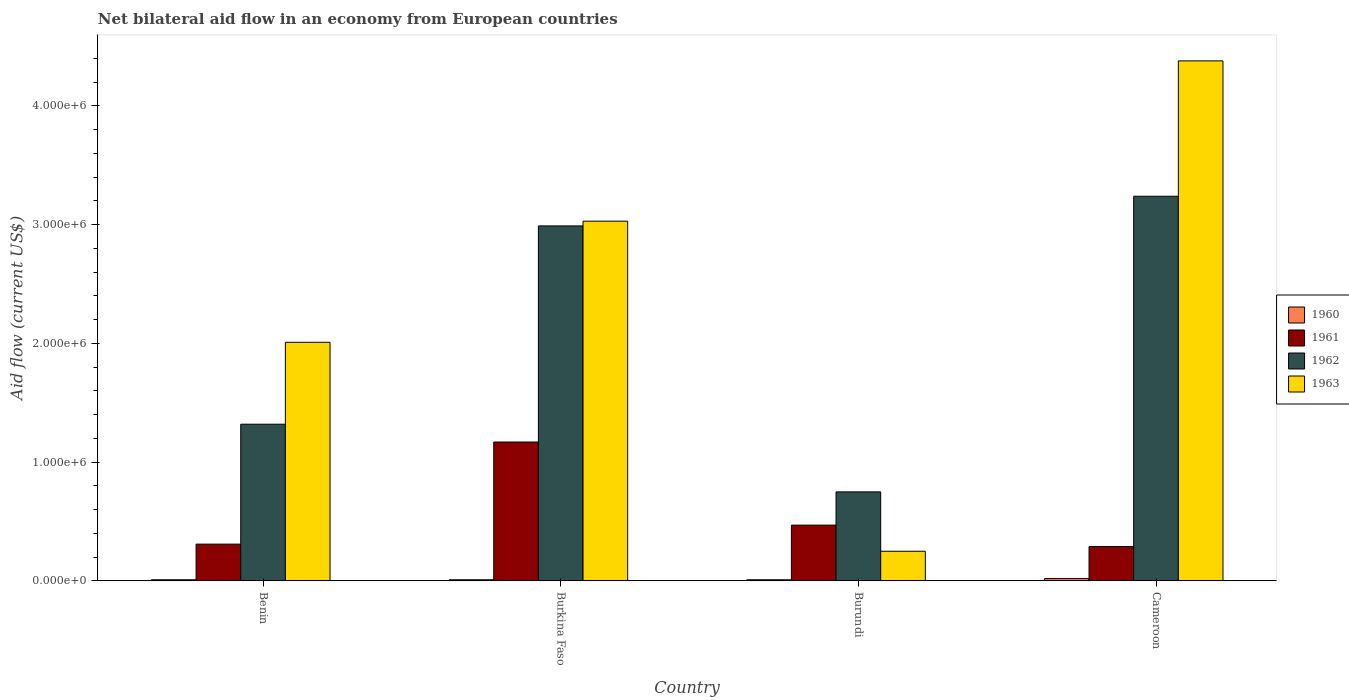How many groups of bars are there?
Ensure brevity in your answer.  4. Are the number of bars per tick equal to the number of legend labels?
Offer a very short reply. Yes. How many bars are there on the 3rd tick from the right?
Your answer should be very brief. 4. What is the label of the 1st group of bars from the left?
Offer a very short reply. Benin. Across all countries, what is the maximum net bilateral aid flow in 1963?
Offer a terse response. 4.38e+06. Across all countries, what is the minimum net bilateral aid flow in 1960?
Ensure brevity in your answer.  10000. In which country was the net bilateral aid flow in 1963 maximum?
Offer a terse response. Cameroon. In which country was the net bilateral aid flow in 1962 minimum?
Offer a very short reply. Burundi. What is the total net bilateral aid flow in 1961 in the graph?
Keep it short and to the point. 2.24e+06. What is the difference between the net bilateral aid flow in 1962 in Burundi and the net bilateral aid flow in 1963 in Burkina Faso?
Make the answer very short. -2.28e+06. What is the average net bilateral aid flow in 1962 per country?
Give a very brief answer. 2.08e+06. What is the difference between the net bilateral aid flow of/in 1961 and net bilateral aid flow of/in 1962 in Burkina Faso?
Keep it short and to the point. -1.82e+06. What is the ratio of the net bilateral aid flow in 1961 in Burkina Faso to that in Burundi?
Your response must be concise. 2.49. Is the net bilateral aid flow in 1960 in Benin less than that in Cameroon?
Offer a terse response. Yes. What is the difference between the highest and the lowest net bilateral aid flow in 1962?
Ensure brevity in your answer.  2.49e+06. In how many countries, is the net bilateral aid flow in 1963 greater than the average net bilateral aid flow in 1963 taken over all countries?
Your response must be concise. 2. Is it the case that in every country, the sum of the net bilateral aid flow in 1960 and net bilateral aid flow in 1962 is greater than the sum of net bilateral aid flow in 1961 and net bilateral aid flow in 1963?
Your answer should be very brief. No. What does the 2nd bar from the left in Cameroon represents?
Keep it short and to the point. 1961. What does the 3rd bar from the right in Cameroon represents?
Your answer should be very brief. 1961. How many bars are there?
Ensure brevity in your answer.  16. Are the values on the major ticks of Y-axis written in scientific E-notation?
Give a very brief answer. Yes. Does the graph contain any zero values?
Give a very brief answer. No. What is the title of the graph?
Give a very brief answer. Net bilateral aid flow in an economy from European countries. Does "1985" appear as one of the legend labels in the graph?
Offer a very short reply. No. What is the Aid flow (current US$) of 1962 in Benin?
Your answer should be very brief. 1.32e+06. What is the Aid flow (current US$) in 1963 in Benin?
Provide a succinct answer. 2.01e+06. What is the Aid flow (current US$) in 1961 in Burkina Faso?
Your answer should be compact. 1.17e+06. What is the Aid flow (current US$) in 1962 in Burkina Faso?
Ensure brevity in your answer.  2.99e+06. What is the Aid flow (current US$) in 1963 in Burkina Faso?
Offer a very short reply. 3.03e+06. What is the Aid flow (current US$) of 1961 in Burundi?
Offer a terse response. 4.70e+05. What is the Aid flow (current US$) in 1962 in Burundi?
Your answer should be compact. 7.50e+05. What is the Aid flow (current US$) of 1960 in Cameroon?
Keep it short and to the point. 2.00e+04. What is the Aid flow (current US$) of 1962 in Cameroon?
Provide a succinct answer. 3.24e+06. What is the Aid flow (current US$) in 1963 in Cameroon?
Give a very brief answer. 4.38e+06. Across all countries, what is the maximum Aid flow (current US$) in 1960?
Your response must be concise. 2.00e+04. Across all countries, what is the maximum Aid flow (current US$) of 1961?
Your answer should be compact. 1.17e+06. Across all countries, what is the maximum Aid flow (current US$) of 1962?
Give a very brief answer. 3.24e+06. Across all countries, what is the maximum Aid flow (current US$) of 1963?
Make the answer very short. 4.38e+06. Across all countries, what is the minimum Aid flow (current US$) in 1961?
Keep it short and to the point. 2.90e+05. Across all countries, what is the minimum Aid flow (current US$) of 1962?
Provide a short and direct response. 7.50e+05. What is the total Aid flow (current US$) in 1960 in the graph?
Provide a succinct answer. 5.00e+04. What is the total Aid flow (current US$) in 1961 in the graph?
Provide a succinct answer. 2.24e+06. What is the total Aid flow (current US$) of 1962 in the graph?
Keep it short and to the point. 8.30e+06. What is the total Aid flow (current US$) in 1963 in the graph?
Ensure brevity in your answer.  9.67e+06. What is the difference between the Aid flow (current US$) in 1960 in Benin and that in Burkina Faso?
Provide a short and direct response. 0. What is the difference between the Aid flow (current US$) of 1961 in Benin and that in Burkina Faso?
Give a very brief answer. -8.60e+05. What is the difference between the Aid flow (current US$) of 1962 in Benin and that in Burkina Faso?
Ensure brevity in your answer.  -1.67e+06. What is the difference between the Aid flow (current US$) in 1963 in Benin and that in Burkina Faso?
Give a very brief answer. -1.02e+06. What is the difference between the Aid flow (current US$) of 1961 in Benin and that in Burundi?
Keep it short and to the point. -1.60e+05. What is the difference between the Aid flow (current US$) in 1962 in Benin and that in Burundi?
Ensure brevity in your answer.  5.70e+05. What is the difference between the Aid flow (current US$) in 1963 in Benin and that in Burundi?
Keep it short and to the point. 1.76e+06. What is the difference between the Aid flow (current US$) of 1960 in Benin and that in Cameroon?
Your answer should be compact. -10000. What is the difference between the Aid flow (current US$) in 1962 in Benin and that in Cameroon?
Your answer should be compact. -1.92e+06. What is the difference between the Aid flow (current US$) of 1963 in Benin and that in Cameroon?
Ensure brevity in your answer.  -2.37e+06. What is the difference between the Aid flow (current US$) of 1961 in Burkina Faso and that in Burundi?
Ensure brevity in your answer.  7.00e+05. What is the difference between the Aid flow (current US$) of 1962 in Burkina Faso and that in Burundi?
Provide a short and direct response. 2.24e+06. What is the difference between the Aid flow (current US$) in 1963 in Burkina Faso and that in Burundi?
Keep it short and to the point. 2.78e+06. What is the difference between the Aid flow (current US$) in 1960 in Burkina Faso and that in Cameroon?
Your response must be concise. -10000. What is the difference between the Aid flow (current US$) in 1961 in Burkina Faso and that in Cameroon?
Ensure brevity in your answer.  8.80e+05. What is the difference between the Aid flow (current US$) in 1962 in Burkina Faso and that in Cameroon?
Offer a terse response. -2.50e+05. What is the difference between the Aid flow (current US$) in 1963 in Burkina Faso and that in Cameroon?
Your answer should be very brief. -1.35e+06. What is the difference between the Aid flow (current US$) in 1960 in Burundi and that in Cameroon?
Keep it short and to the point. -10000. What is the difference between the Aid flow (current US$) in 1961 in Burundi and that in Cameroon?
Provide a succinct answer. 1.80e+05. What is the difference between the Aid flow (current US$) of 1962 in Burundi and that in Cameroon?
Offer a very short reply. -2.49e+06. What is the difference between the Aid flow (current US$) of 1963 in Burundi and that in Cameroon?
Keep it short and to the point. -4.13e+06. What is the difference between the Aid flow (current US$) of 1960 in Benin and the Aid flow (current US$) of 1961 in Burkina Faso?
Offer a very short reply. -1.16e+06. What is the difference between the Aid flow (current US$) in 1960 in Benin and the Aid flow (current US$) in 1962 in Burkina Faso?
Offer a terse response. -2.98e+06. What is the difference between the Aid flow (current US$) of 1960 in Benin and the Aid flow (current US$) of 1963 in Burkina Faso?
Give a very brief answer. -3.02e+06. What is the difference between the Aid flow (current US$) of 1961 in Benin and the Aid flow (current US$) of 1962 in Burkina Faso?
Offer a terse response. -2.68e+06. What is the difference between the Aid flow (current US$) in 1961 in Benin and the Aid flow (current US$) in 1963 in Burkina Faso?
Provide a short and direct response. -2.72e+06. What is the difference between the Aid flow (current US$) of 1962 in Benin and the Aid flow (current US$) of 1963 in Burkina Faso?
Your response must be concise. -1.71e+06. What is the difference between the Aid flow (current US$) in 1960 in Benin and the Aid flow (current US$) in 1961 in Burundi?
Provide a succinct answer. -4.60e+05. What is the difference between the Aid flow (current US$) of 1960 in Benin and the Aid flow (current US$) of 1962 in Burundi?
Keep it short and to the point. -7.40e+05. What is the difference between the Aid flow (current US$) in 1961 in Benin and the Aid flow (current US$) in 1962 in Burundi?
Provide a short and direct response. -4.40e+05. What is the difference between the Aid flow (current US$) of 1961 in Benin and the Aid flow (current US$) of 1963 in Burundi?
Your answer should be very brief. 6.00e+04. What is the difference between the Aid flow (current US$) in 1962 in Benin and the Aid flow (current US$) in 1963 in Burundi?
Keep it short and to the point. 1.07e+06. What is the difference between the Aid flow (current US$) of 1960 in Benin and the Aid flow (current US$) of 1961 in Cameroon?
Provide a short and direct response. -2.80e+05. What is the difference between the Aid flow (current US$) in 1960 in Benin and the Aid flow (current US$) in 1962 in Cameroon?
Your response must be concise. -3.23e+06. What is the difference between the Aid flow (current US$) of 1960 in Benin and the Aid flow (current US$) of 1963 in Cameroon?
Make the answer very short. -4.37e+06. What is the difference between the Aid flow (current US$) of 1961 in Benin and the Aid flow (current US$) of 1962 in Cameroon?
Ensure brevity in your answer.  -2.93e+06. What is the difference between the Aid flow (current US$) in 1961 in Benin and the Aid flow (current US$) in 1963 in Cameroon?
Make the answer very short. -4.07e+06. What is the difference between the Aid flow (current US$) of 1962 in Benin and the Aid flow (current US$) of 1963 in Cameroon?
Offer a very short reply. -3.06e+06. What is the difference between the Aid flow (current US$) of 1960 in Burkina Faso and the Aid flow (current US$) of 1961 in Burundi?
Make the answer very short. -4.60e+05. What is the difference between the Aid flow (current US$) of 1960 in Burkina Faso and the Aid flow (current US$) of 1962 in Burundi?
Your answer should be compact. -7.40e+05. What is the difference between the Aid flow (current US$) in 1961 in Burkina Faso and the Aid flow (current US$) in 1963 in Burundi?
Provide a short and direct response. 9.20e+05. What is the difference between the Aid flow (current US$) of 1962 in Burkina Faso and the Aid flow (current US$) of 1963 in Burundi?
Ensure brevity in your answer.  2.74e+06. What is the difference between the Aid flow (current US$) of 1960 in Burkina Faso and the Aid flow (current US$) of 1961 in Cameroon?
Provide a succinct answer. -2.80e+05. What is the difference between the Aid flow (current US$) of 1960 in Burkina Faso and the Aid flow (current US$) of 1962 in Cameroon?
Your answer should be compact. -3.23e+06. What is the difference between the Aid flow (current US$) in 1960 in Burkina Faso and the Aid flow (current US$) in 1963 in Cameroon?
Make the answer very short. -4.37e+06. What is the difference between the Aid flow (current US$) in 1961 in Burkina Faso and the Aid flow (current US$) in 1962 in Cameroon?
Give a very brief answer. -2.07e+06. What is the difference between the Aid flow (current US$) in 1961 in Burkina Faso and the Aid flow (current US$) in 1963 in Cameroon?
Make the answer very short. -3.21e+06. What is the difference between the Aid flow (current US$) of 1962 in Burkina Faso and the Aid flow (current US$) of 1963 in Cameroon?
Provide a short and direct response. -1.39e+06. What is the difference between the Aid flow (current US$) of 1960 in Burundi and the Aid flow (current US$) of 1961 in Cameroon?
Provide a succinct answer. -2.80e+05. What is the difference between the Aid flow (current US$) in 1960 in Burundi and the Aid flow (current US$) in 1962 in Cameroon?
Offer a terse response. -3.23e+06. What is the difference between the Aid flow (current US$) in 1960 in Burundi and the Aid flow (current US$) in 1963 in Cameroon?
Offer a terse response. -4.37e+06. What is the difference between the Aid flow (current US$) of 1961 in Burundi and the Aid flow (current US$) of 1962 in Cameroon?
Provide a short and direct response. -2.77e+06. What is the difference between the Aid flow (current US$) of 1961 in Burundi and the Aid flow (current US$) of 1963 in Cameroon?
Make the answer very short. -3.91e+06. What is the difference between the Aid flow (current US$) of 1962 in Burundi and the Aid flow (current US$) of 1963 in Cameroon?
Make the answer very short. -3.63e+06. What is the average Aid flow (current US$) of 1960 per country?
Make the answer very short. 1.25e+04. What is the average Aid flow (current US$) of 1961 per country?
Offer a terse response. 5.60e+05. What is the average Aid flow (current US$) in 1962 per country?
Make the answer very short. 2.08e+06. What is the average Aid flow (current US$) of 1963 per country?
Provide a succinct answer. 2.42e+06. What is the difference between the Aid flow (current US$) of 1960 and Aid flow (current US$) of 1962 in Benin?
Ensure brevity in your answer.  -1.31e+06. What is the difference between the Aid flow (current US$) in 1961 and Aid flow (current US$) in 1962 in Benin?
Offer a very short reply. -1.01e+06. What is the difference between the Aid flow (current US$) of 1961 and Aid flow (current US$) of 1963 in Benin?
Make the answer very short. -1.70e+06. What is the difference between the Aid flow (current US$) in 1962 and Aid flow (current US$) in 1963 in Benin?
Make the answer very short. -6.90e+05. What is the difference between the Aid flow (current US$) in 1960 and Aid flow (current US$) in 1961 in Burkina Faso?
Offer a very short reply. -1.16e+06. What is the difference between the Aid flow (current US$) of 1960 and Aid flow (current US$) of 1962 in Burkina Faso?
Ensure brevity in your answer.  -2.98e+06. What is the difference between the Aid flow (current US$) in 1960 and Aid flow (current US$) in 1963 in Burkina Faso?
Your response must be concise. -3.02e+06. What is the difference between the Aid flow (current US$) of 1961 and Aid flow (current US$) of 1962 in Burkina Faso?
Provide a short and direct response. -1.82e+06. What is the difference between the Aid flow (current US$) of 1961 and Aid flow (current US$) of 1963 in Burkina Faso?
Provide a succinct answer. -1.86e+06. What is the difference between the Aid flow (current US$) of 1962 and Aid flow (current US$) of 1963 in Burkina Faso?
Offer a very short reply. -4.00e+04. What is the difference between the Aid flow (current US$) of 1960 and Aid flow (current US$) of 1961 in Burundi?
Make the answer very short. -4.60e+05. What is the difference between the Aid flow (current US$) of 1960 and Aid flow (current US$) of 1962 in Burundi?
Ensure brevity in your answer.  -7.40e+05. What is the difference between the Aid flow (current US$) of 1961 and Aid flow (current US$) of 1962 in Burundi?
Ensure brevity in your answer.  -2.80e+05. What is the difference between the Aid flow (current US$) in 1961 and Aid flow (current US$) in 1963 in Burundi?
Provide a short and direct response. 2.20e+05. What is the difference between the Aid flow (current US$) in 1962 and Aid flow (current US$) in 1963 in Burundi?
Your answer should be very brief. 5.00e+05. What is the difference between the Aid flow (current US$) in 1960 and Aid flow (current US$) in 1961 in Cameroon?
Give a very brief answer. -2.70e+05. What is the difference between the Aid flow (current US$) of 1960 and Aid flow (current US$) of 1962 in Cameroon?
Your response must be concise. -3.22e+06. What is the difference between the Aid flow (current US$) of 1960 and Aid flow (current US$) of 1963 in Cameroon?
Your answer should be very brief. -4.36e+06. What is the difference between the Aid flow (current US$) in 1961 and Aid flow (current US$) in 1962 in Cameroon?
Provide a short and direct response. -2.95e+06. What is the difference between the Aid flow (current US$) of 1961 and Aid flow (current US$) of 1963 in Cameroon?
Ensure brevity in your answer.  -4.09e+06. What is the difference between the Aid flow (current US$) in 1962 and Aid flow (current US$) in 1963 in Cameroon?
Make the answer very short. -1.14e+06. What is the ratio of the Aid flow (current US$) of 1961 in Benin to that in Burkina Faso?
Give a very brief answer. 0.27. What is the ratio of the Aid flow (current US$) in 1962 in Benin to that in Burkina Faso?
Make the answer very short. 0.44. What is the ratio of the Aid flow (current US$) in 1963 in Benin to that in Burkina Faso?
Your answer should be very brief. 0.66. What is the ratio of the Aid flow (current US$) of 1960 in Benin to that in Burundi?
Keep it short and to the point. 1. What is the ratio of the Aid flow (current US$) of 1961 in Benin to that in Burundi?
Offer a terse response. 0.66. What is the ratio of the Aid flow (current US$) in 1962 in Benin to that in Burundi?
Your answer should be compact. 1.76. What is the ratio of the Aid flow (current US$) of 1963 in Benin to that in Burundi?
Your answer should be very brief. 8.04. What is the ratio of the Aid flow (current US$) in 1961 in Benin to that in Cameroon?
Your response must be concise. 1.07. What is the ratio of the Aid flow (current US$) in 1962 in Benin to that in Cameroon?
Give a very brief answer. 0.41. What is the ratio of the Aid flow (current US$) in 1963 in Benin to that in Cameroon?
Your answer should be compact. 0.46. What is the ratio of the Aid flow (current US$) of 1960 in Burkina Faso to that in Burundi?
Provide a short and direct response. 1. What is the ratio of the Aid flow (current US$) of 1961 in Burkina Faso to that in Burundi?
Provide a short and direct response. 2.49. What is the ratio of the Aid flow (current US$) of 1962 in Burkina Faso to that in Burundi?
Your answer should be very brief. 3.99. What is the ratio of the Aid flow (current US$) in 1963 in Burkina Faso to that in Burundi?
Your answer should be very brief. 12.12. What is the ratio of the Aid flow (current US$) in 1960 in Burkina Faso to that in Cameroon?
Make the answer very short. 0.5. What is the ratio of the Aid flow (current US$) in 1961 in Burkina Faso to that in Cameroon?
Ensure brevity in your answer.  4.03. What is the ratio of the Aid flow (current US$) of 1962 in Burkina Faso to that in Cameroon?
Your response must be concise. 0.92. What is the ratio of the Aid flow (current US$) in 1963 in Burkina Faso to that in Cameroon?
Make the answer very short. 0.69. What is the ratio of the Aid flow (current US$) of 1961 in Burundi to that in Cameroon?
Ensure brevity in your answer.  1.62. What is the ratio of the Aid flow (current US$) of 1962 in Burundi to that in Cameroon?
Give a very brief answer. 0.23. What is the ratio of the Aid flow (current US$) in 1963 in Burundi to that in Cameroon?
Your answer should be very brief. 0.06. What is the difference between the highest and the second highest Aid flow (current US$) in 1962?
Provide a succinct answer. 2.50e+05. What is the difference between the highest and the second highest Aid flow (current US$) of 1963?
Your answer should be compact. 1.35e+06. What is the difference between the highest and the lowest Aid flow (current US$) in 1961?
Your answer should be very brief. 8.80e+05. What is the difference between the highest and the lowest Aid flow (current US$) of 1962?
Give a very brief answer. 2.49e+06. What is the difference between the highest and the lowest Aid flow (current US$) of 1963?
Provide a succinct answer. 4.13e+06. 